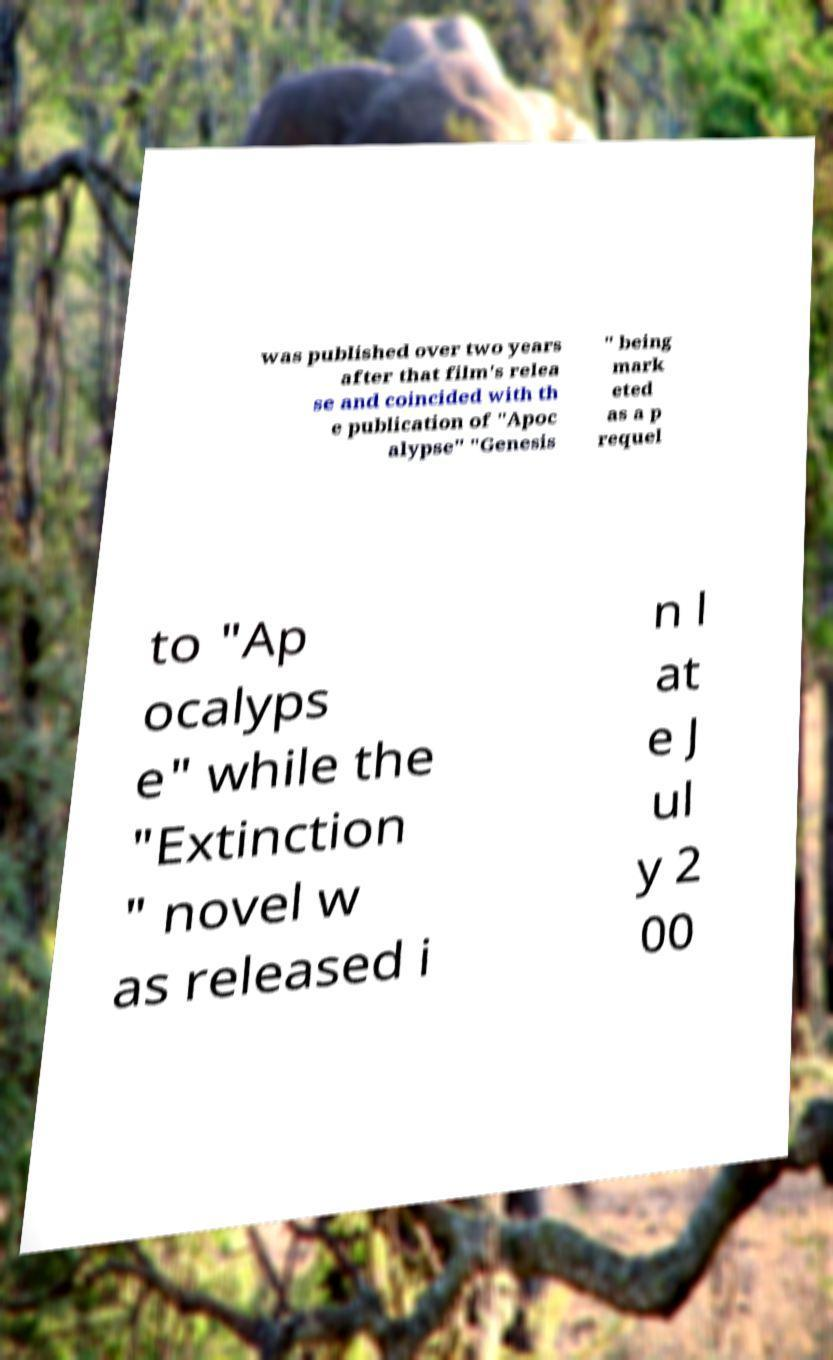For documentation purposes, I need the text within this image transcribed. Could you provide that? was published over two years after that film's relea se and coincided with th e publication of "Apoc alypse" "Genesis " being mark eted as a p requel to "Ap ocalyps e" while the "Extinction " novel w as released i n l at e J ul y 2 00 